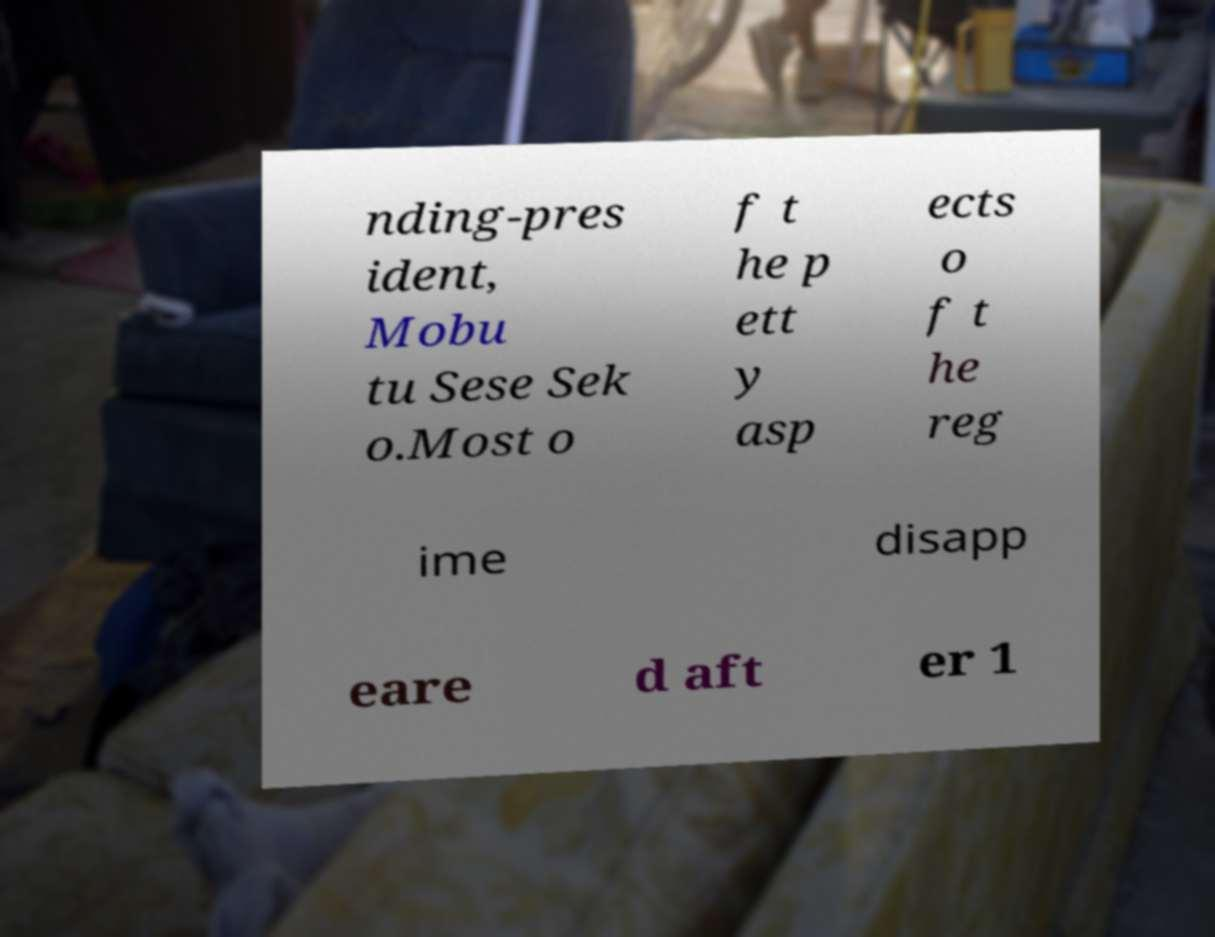Please identify and transcribe the text found in this image. nding-pres ident, Mobu tu Sese Sek o.Most o f t he p ett y asp ects o f t he reg ime disapp eare d aft er 1 